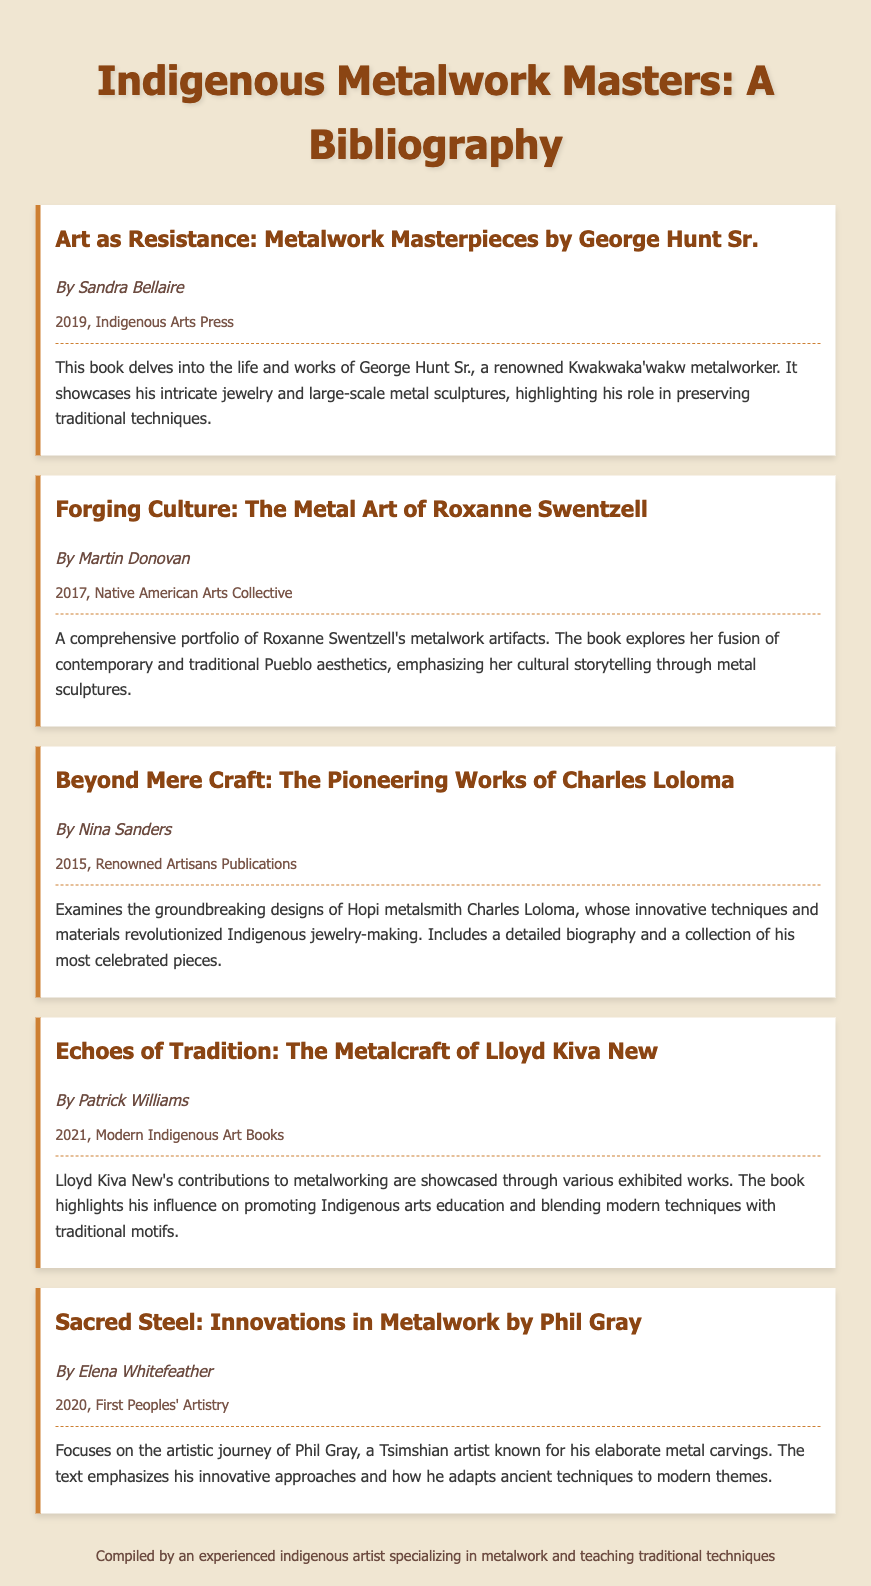What is the title of the first bibliography item? The title of the first bibliography item is given at the start of the entry and is "Art as Resistance: Metalwork Masterpieces by George Hunt Sr."
Answer: Art as Resistance: Metalwork Masterpieces by George Hunt Sr Who is the author of the book on Roxanne Swentzell? This information can be found in the bibliography entry for Roxanne Swentzell, which states that it is authored by Martin Donovan.
Answer: Martin Donovan In what year was "Beyond Mere Craft" published? The publication year for "Beyond Mere Craft" is specified in the entry as 2015.
Answer: 2015 How does Phil Gray's work relate to his heritage? The summary in the bibliography entry describes Phil Gray's work as being known for his elaborate metal carvings that adapt ancient techniques, indicating a connection to his heritage.
Answer: elaborate metal carvings Which artist's biography emphasizes their role in preserving traditional techniques? This is mentioned in the summary of George Hunt Sr.'s entry, highlighting his role in preserving traditional techniques.
Answer: George Hunt Sr What publishing house released the book about Lloyd Kiva New? This information is available in the entry for Lloyd Kiva New, which states that it was published by Modern Indigenous Art Books.
Answer: Modern Indigenous Art Books Which biography includes a detailed collection of celebrated pieces? The entry for Charles Loloma mentions that it includes a detailed biography and a collection of his most celebrated pieces.
Answer: Charles Loloma What is the main theme of Roxanne Swentzell's metalwork? The summary of Roxanne Swentzell's book indicates that the main theme is cultural storytelling through metal sculptures.
Answer: cultural storytelling 